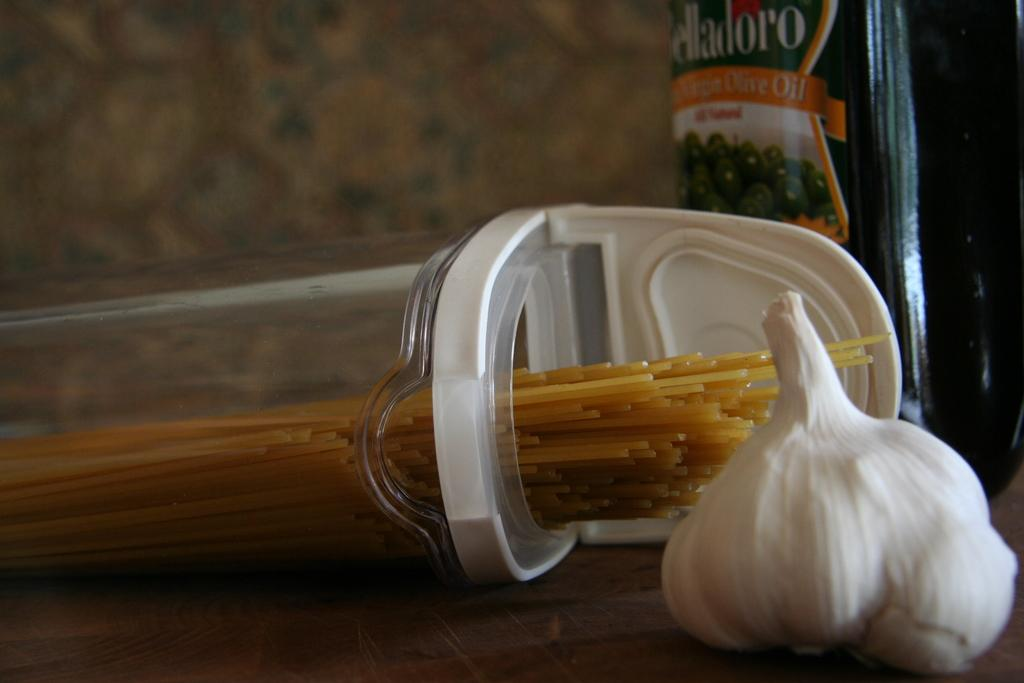What type of food item can be seen on the table in the image? There is garlic on the table. What else is present on the table besides the garlic? There is a container and a food packet on the table. What type of food is visible on the table? There is spaghetti on the table. What type of cord is used to hold the spaghetti in the image? There is no cord present in the image; the spaghetti is not held by any cord. How many people are attending the party in the image? There is no party depicted in the image; it only shows items on a table. 